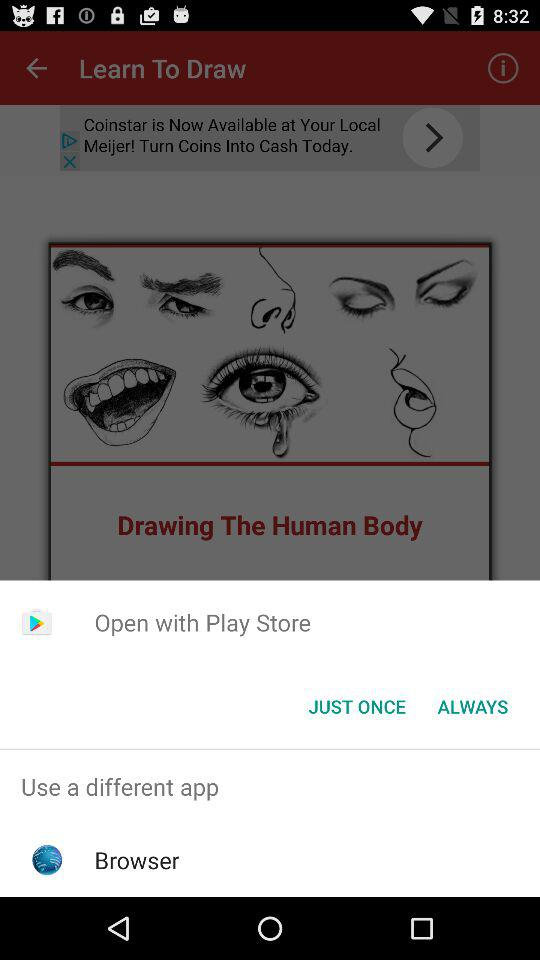What are the options for opening the content? The options are "Play Store" and "Browser". 